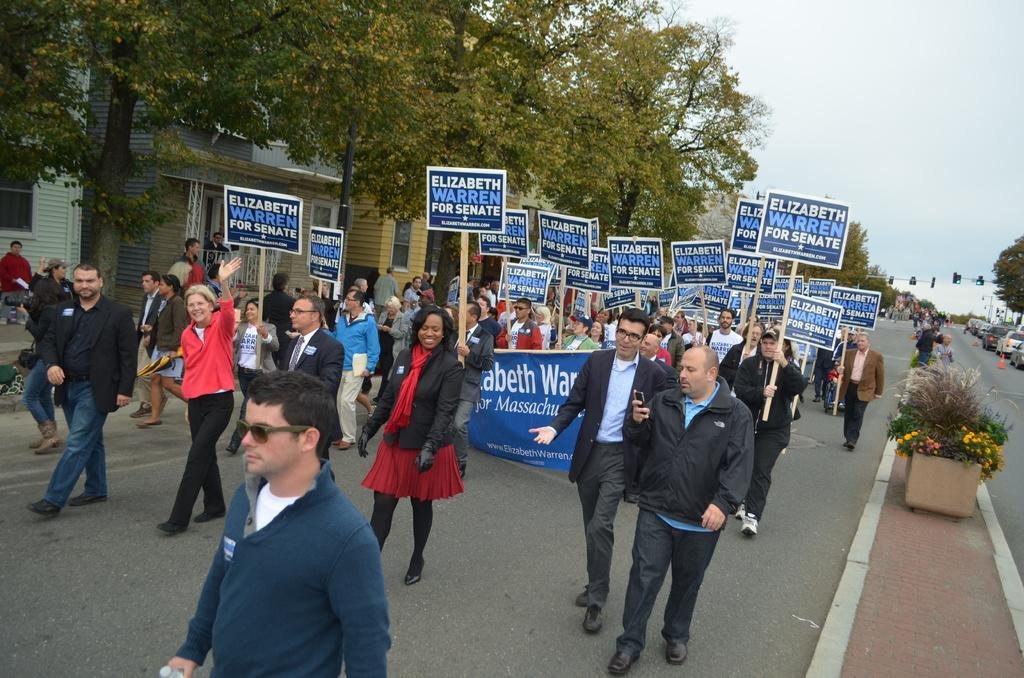What are the people in the image holding? The people in the image are holding boards and a banner. What type of natural environment can be seen in the image? There are trees visible in the image. What type of man-made structures can be seen in the image? There are buildings in the image. What else can be seen in the image besides people, trees, and buildings? There are vehicles in the image. How many frogs are sitting on the banner in the image? There are no frogs present in the image, so it is not possible to determine how many might be sitting on the banner. 